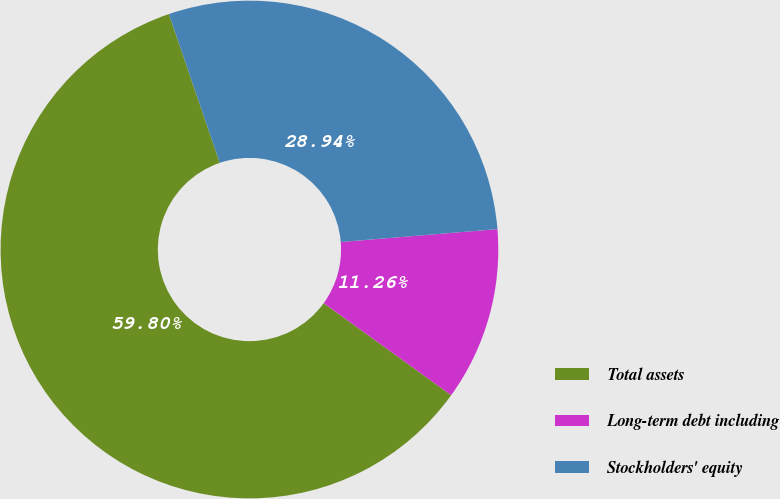<chart> <loc_0><loc_0><loc_500><loc_500><pie_chart><fcel>Total assets<fcel>Long-term debt including<fcel>Stockholders' equity<nl><fcel>59.8%<fcel>11.26%<fcel>28.94%<nl></chart> 